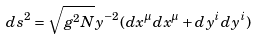Convert formula to latex. <formula><loc_0><loc_0><loc_500><loc_500>d s ^ { 2 } = \sqrt { g ^ { 2 } N } y ^ { - 2 } ( d x ^ { \mu } d x ^ { \mu } + d y ^ { i } d y ^ { i } )</formula> 